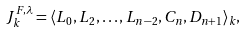Convert formula to latex. <formula><loc_0><loc_0><loc_500><loc_500>J ^ { F , \lambda } _ { k } = \langle L _ { 0 } , L _ { 2 } , \dots , L _ { n - 2 } , C _ { n } , D _ { n + 1 } \rangle _ { k } ,</formula> 